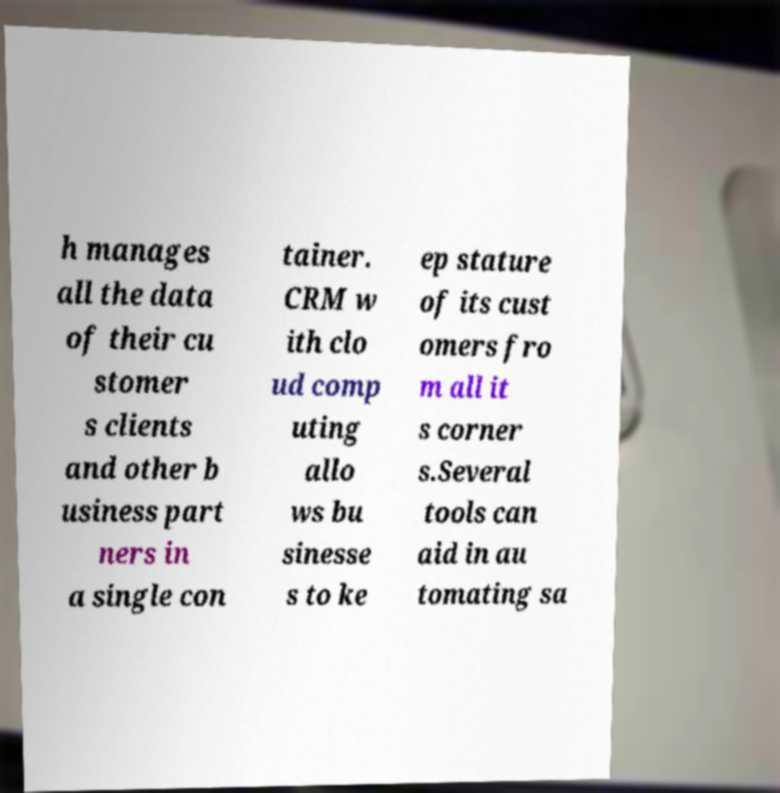Could you extract and type out the text from this image? h manages all the data of their cu stomer s clients and other b usiness part ners in a single con tainer. CRM w ith clo ud comp uting allo ws bu sinesse s to ke ep stature of its cust omers fro m all it s corner s.Several tools can aid in au tomating sa 